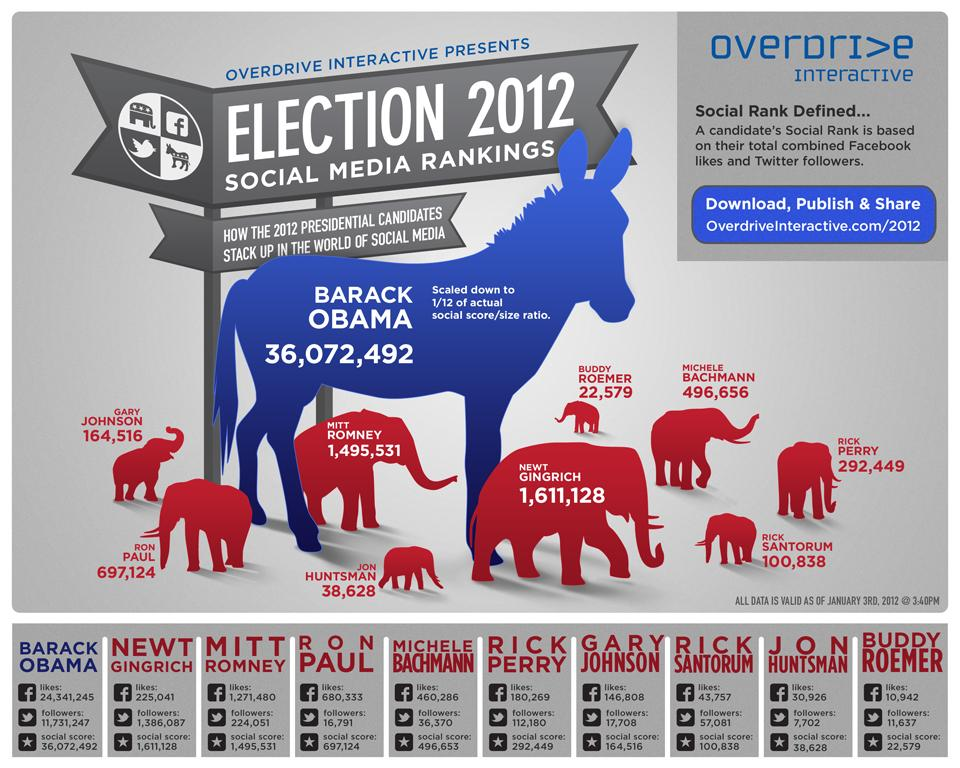Indicate a few pertinent items in this graphic. As of January 3, 2012, Barack Obama had 11,731,247 people following him on Twitter. As of January 3, 2012, Mitt Romney had 1,271,480 Facebook likes. Barack Obama was the presidential candidate in the 2012 U.S. Election who had the highest social score. 